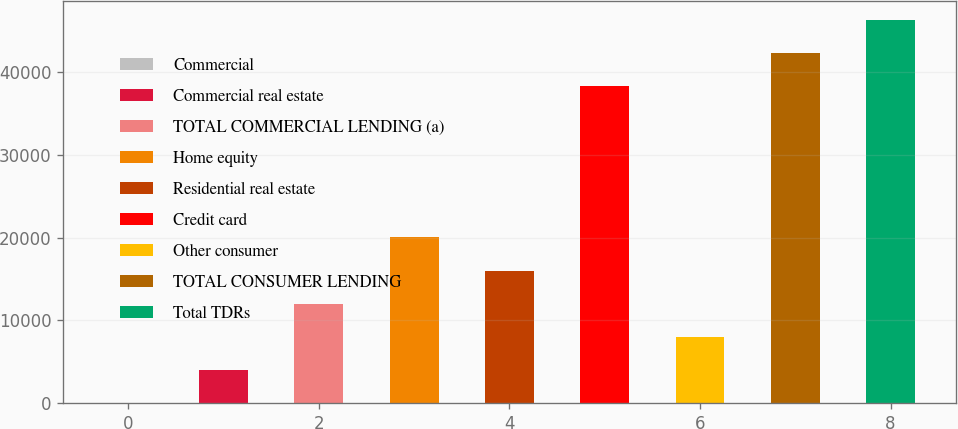<chart> <loc_0><loc_0><loc_500><loc_500><bar_chart><fcel>Commercial<fcel>Commercial real estate<fcel>TOTAL COMMERCIAL LENDING (a)<fcel>Home equity<fcel>Residential real estate<fcel>Credit card<fcel>Other consumer<fcel>TOTAL CONSUMER LENDING<fcel>Total TDRs<nl><fcel>37<fcel>4030.1<fcel>12016.3<fcel>20002.5<fcel>16009.4<fcel>38256<fcel>8023.2<fcel>42249.1<fcel>46242.2<nl></chart> 